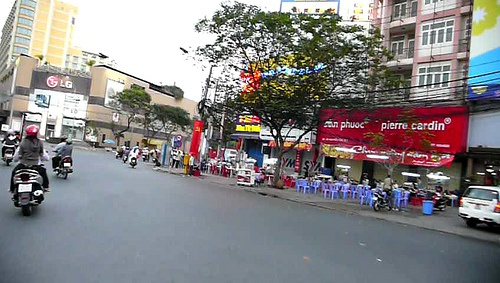Describe the objects in this image and their specific colors. I can see car in white, lightgray, black, darkgray, and gray tones, motorcycle in white, black, gray, and darkgray tones, people in white, black, gray, darkgray, and lavender tones, people in white, black, gray, and darkgray tones, and chair in white, blue, and gray tones in this image. 